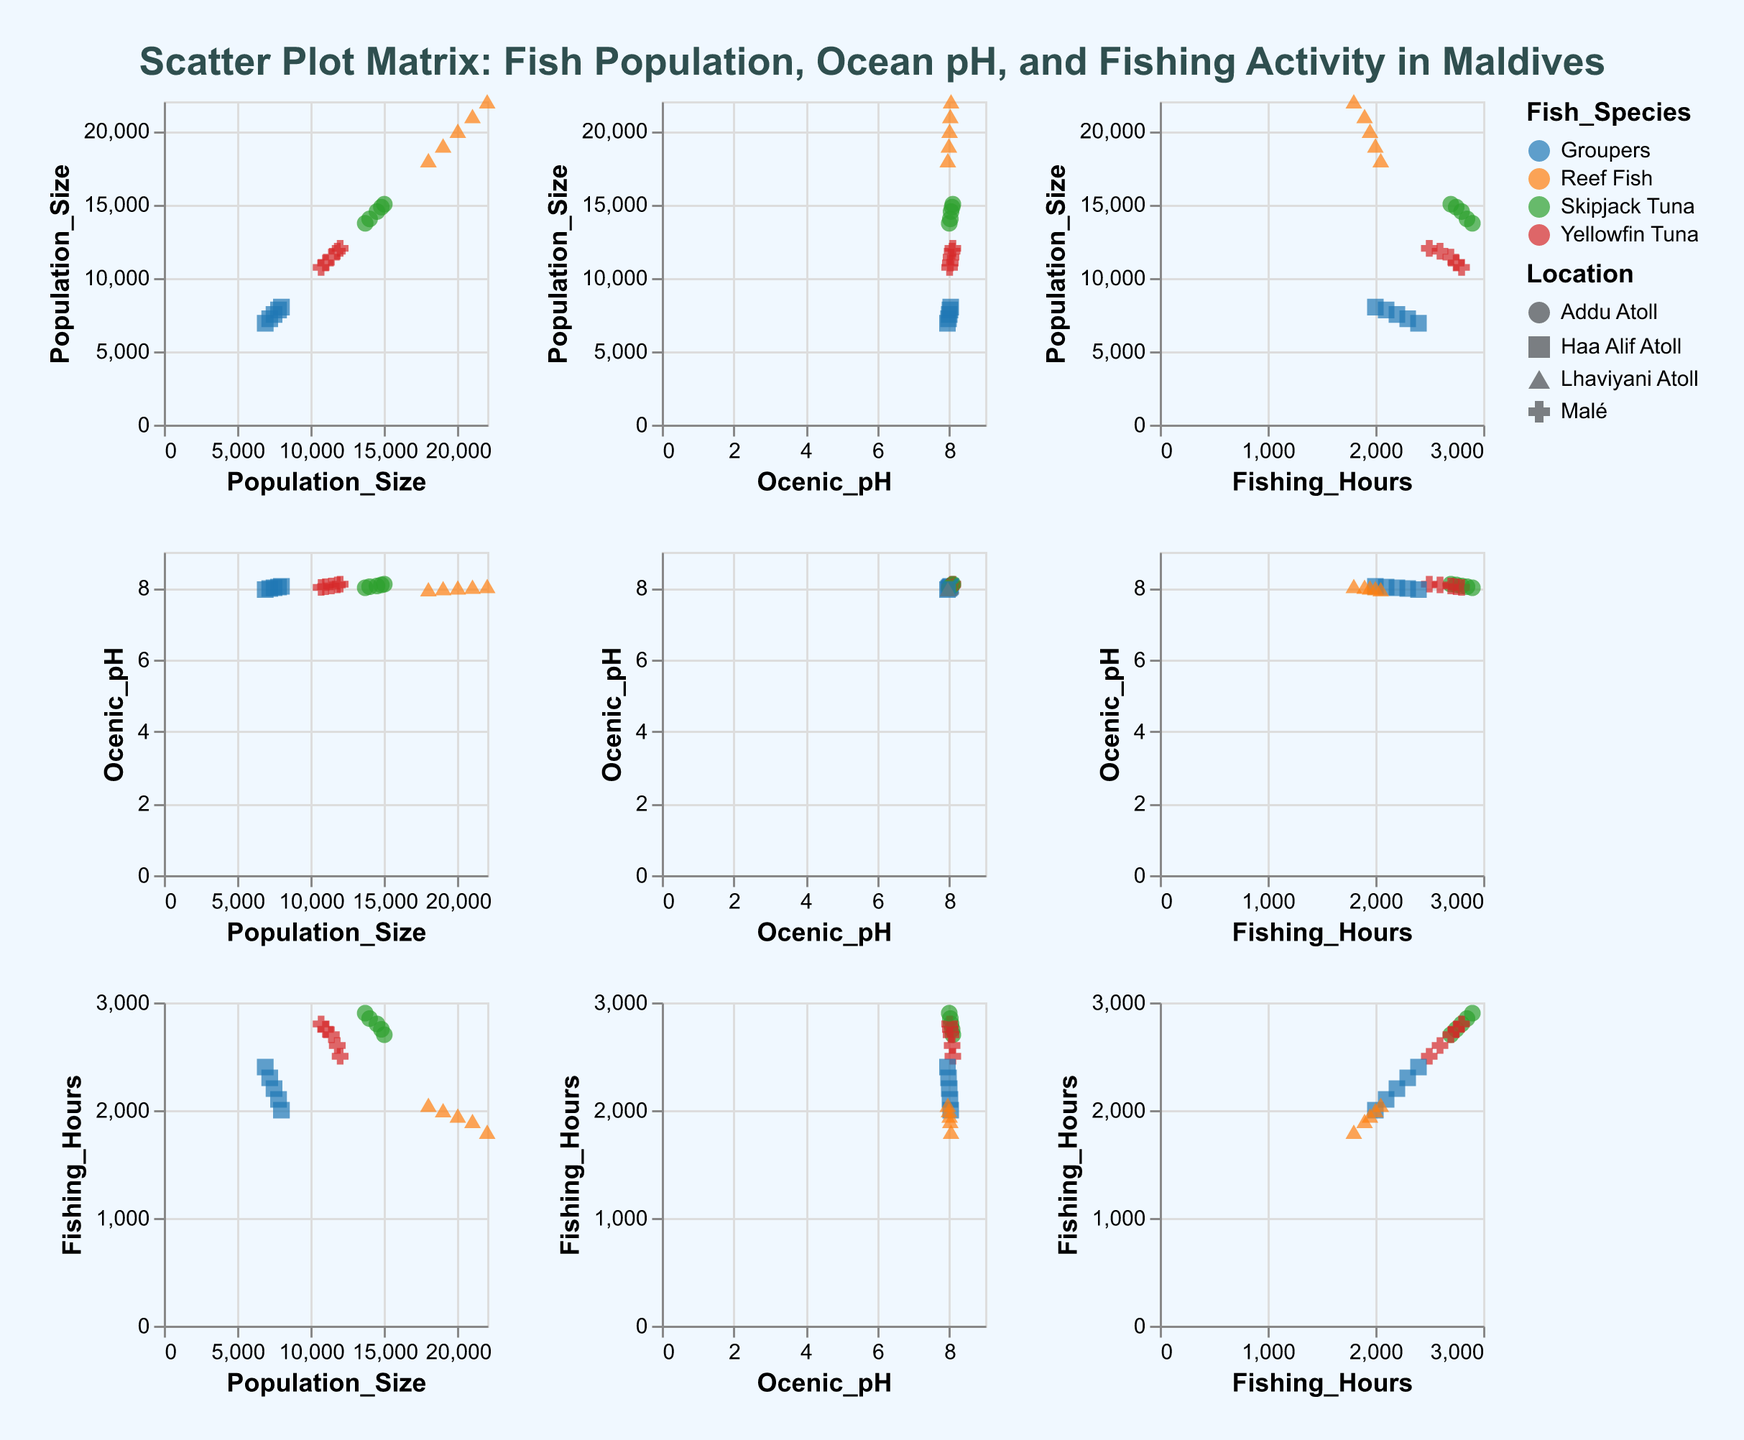What is the title of the figure? The title is displayed at the top center of the figure in a larger, bold font.
Answer: Scatter Plot Matrix: Fish Population, Ocean pH, and Fishing Activity in Maldives How many fish species are represented in the figure? There are different colors used to distinguish between fish species in the scatter plot matrix. By examining the legend, we see four different fish species.
Answer: Four What color represents "Reef Fish"? The legend indicates the color used for "Reef Fish". According to the legend, "Reef Fish" is represented by green.
Answer: Green Which location has the highest Population Size in 2018? By looking at the points in the scatter plot matrix corresponding to Population Size for the year 2018, we can see that the highest value is represented in one of the locations. "Lhaviyani Atoll" reaches the highest value for Population Size in 2018.
Answer: Lhaviyani Atoll How does the Population Size of Groupers change from 2018 to 2022? By checking the scatter plot matrix and observing the points representing Groupers each year from 2018 to 2022, we can notice a trend. Groupers' population size decreases from 8000 in 2018 to 6900 in 2022.
Answer: Decreases What is the trend between Fishing Hours and Oceanic pH for "Yellowfin Tuna"? We can observe scatter plots showing the relationship between Fishing Hours and Oceanic pH for different fish species. By focusing on the points representing "Yellowfin Tuna," we can detect a slight downward trend, indicating that as Oceanic pH decreases, Fishing Hours tend to increase.
Answer: Slight downward trend Which fish species appears to have the largest decline in Population Size over the years? By examining the scatter plot matrix and comparing Population Size across years for each fish species, we can observe which species have the largest decline. Groupers have the most significant decline in Population Size.
Answer: Groupers In 2022, which fish species had the highest Fishing Hours? The scatter plot matrix can show Fishing Hours for different fish species across years. By focusing on the year 2022, we can see which species had the highest value. Skipjack Tuna had the highest Fishing Hours in 2022.
Answer: Skipjack Tuna Is there a noticeable correlation between Population Size and Oceanic pH for the data points overall? By looking at the scatter plots that cross-reference Population Size and Oceanic pH for all fish species and locations, we can observe whether points form a specific trend, indicating correlation. There does not appear to be a strong, noticeable correlation between Population Size and Oceanic pH overall.
Answer: No strong correlation 